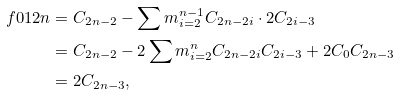Convert formula to latex. <formula><loc_0><loc_0><loc_500><loc_500>\ f { 0 1 } { 2 n } & = C _ { 2 n - 2 } - \sum m _ { i = 2 } ^ { n - 1 } C _ { 2 n - 2 i } \cdot 2 C _ { 2 i - 3 } \\ & = C _ { 2 n - 2 } - 2 \sum m _ { i = 2 } ^ { n } C _ { 2 n - 2 i } C _ { 2 i - 3 } + 2 C _ { 0 } C _ { 2 n - 3 } \\ & = 2 C _ { 2 n - 3 } , \\</formula> 